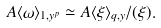<formula> <loc_0><loc_0><loc_500><loc_500>A \langle \omega \rangle _ { 1 , y ^ { p } } \simeq A \langle \xi \rangle _ { q , y } / ( \xi ) .</formula> 